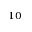<formula> <loc_0><loc_0><loc_500><loc_500>^ { 1 0 }</formula> 